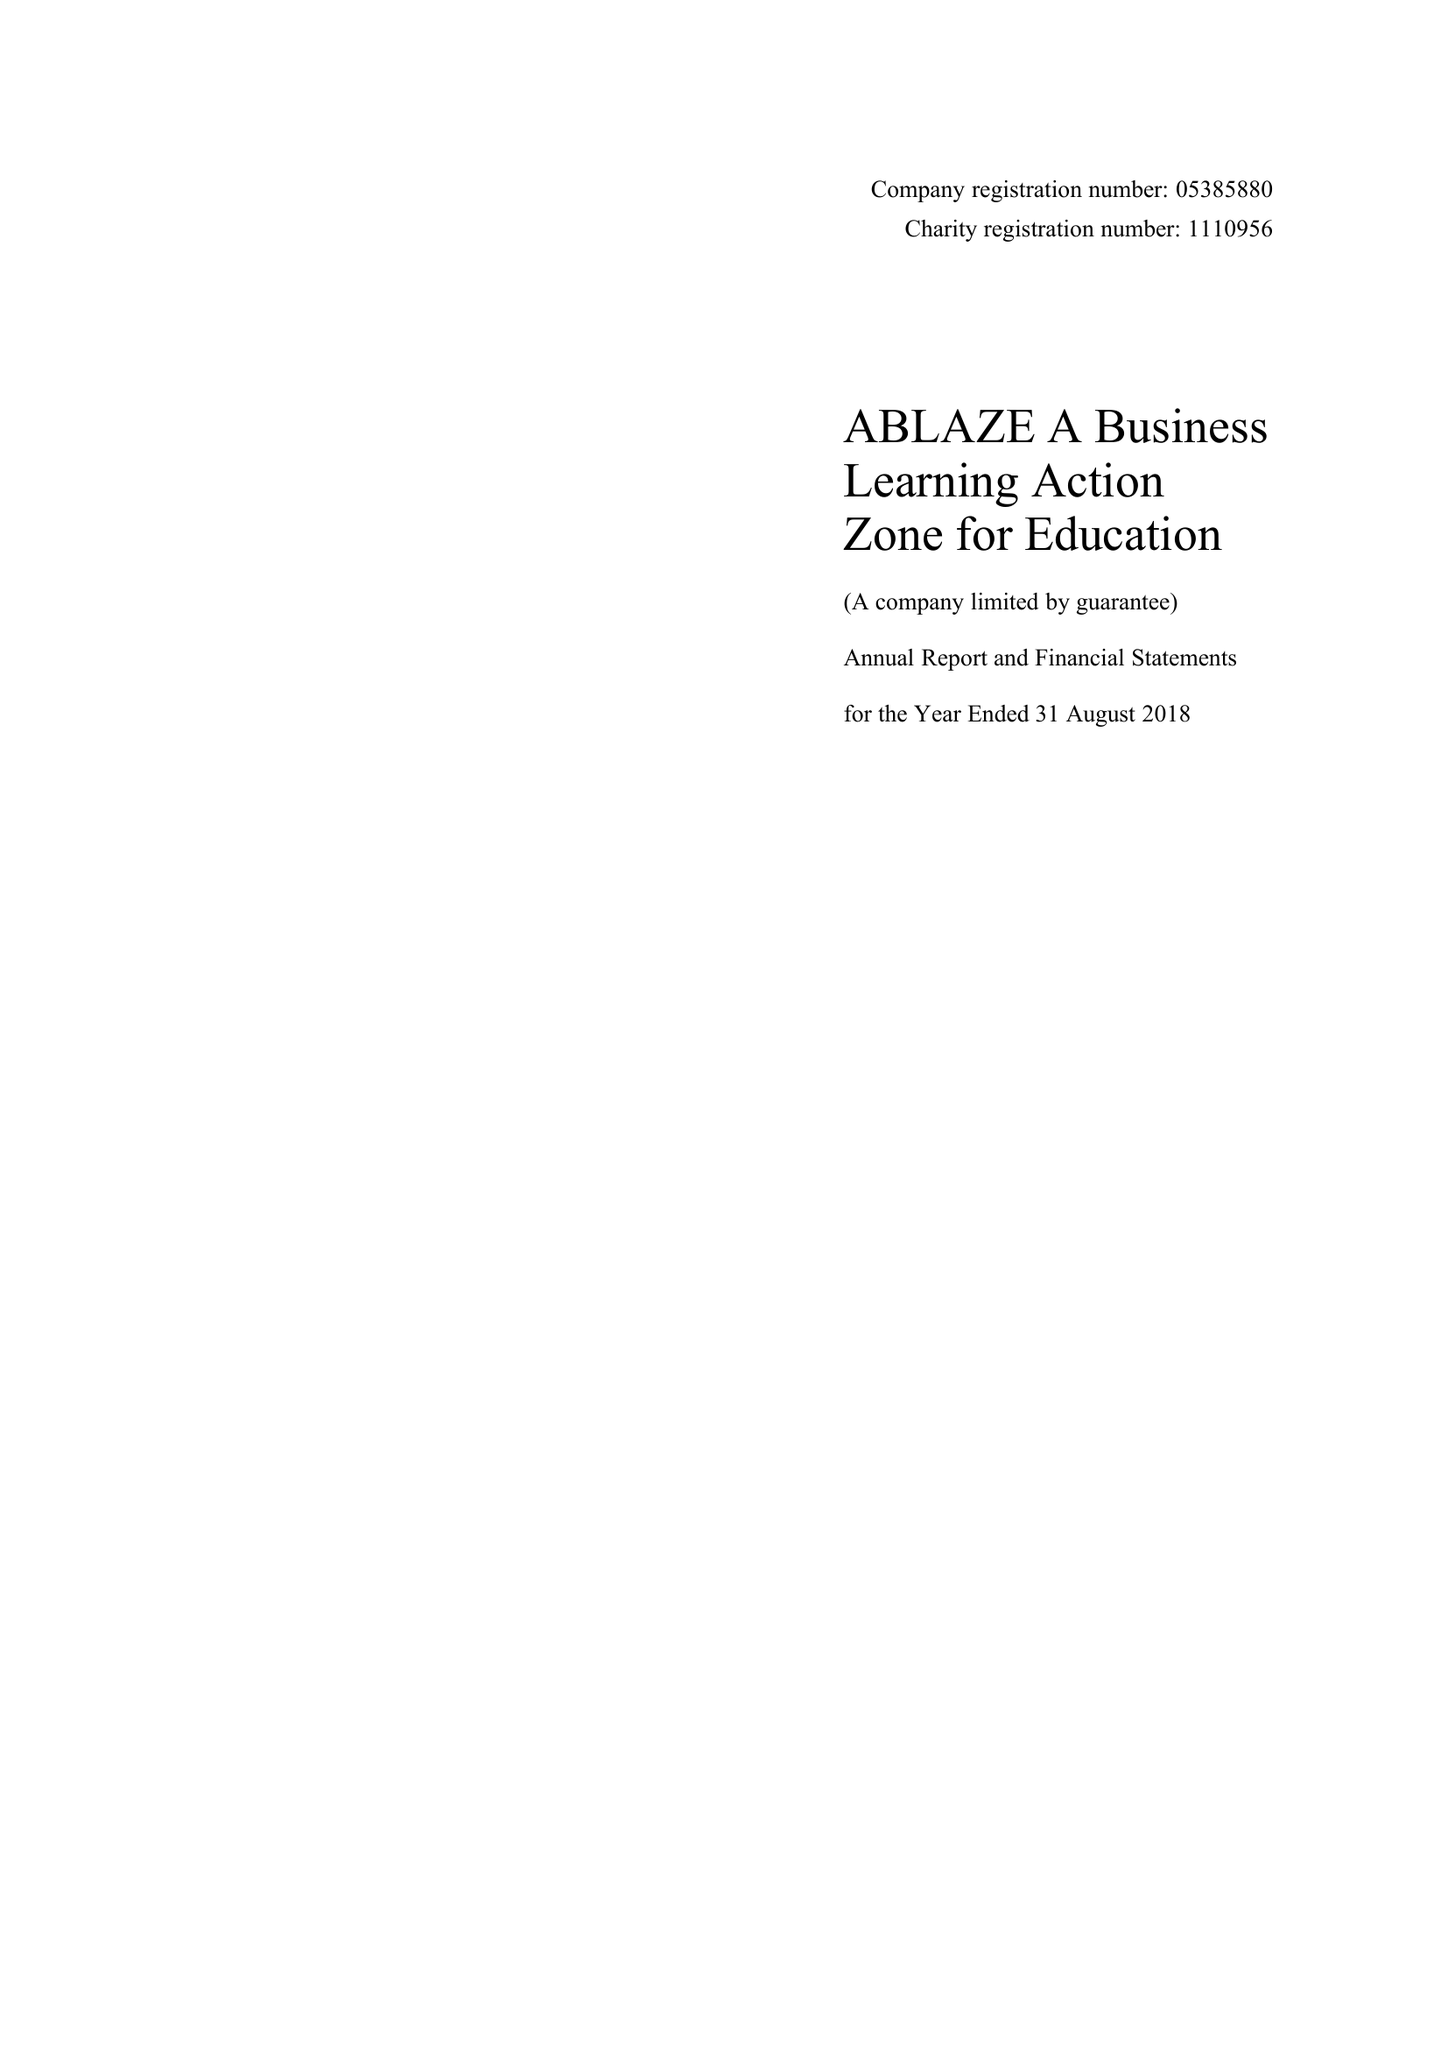What is the value for the charity_name?
Answer the question using a single word or phrase. Ablaze A Business Learning Action Zone For Education 